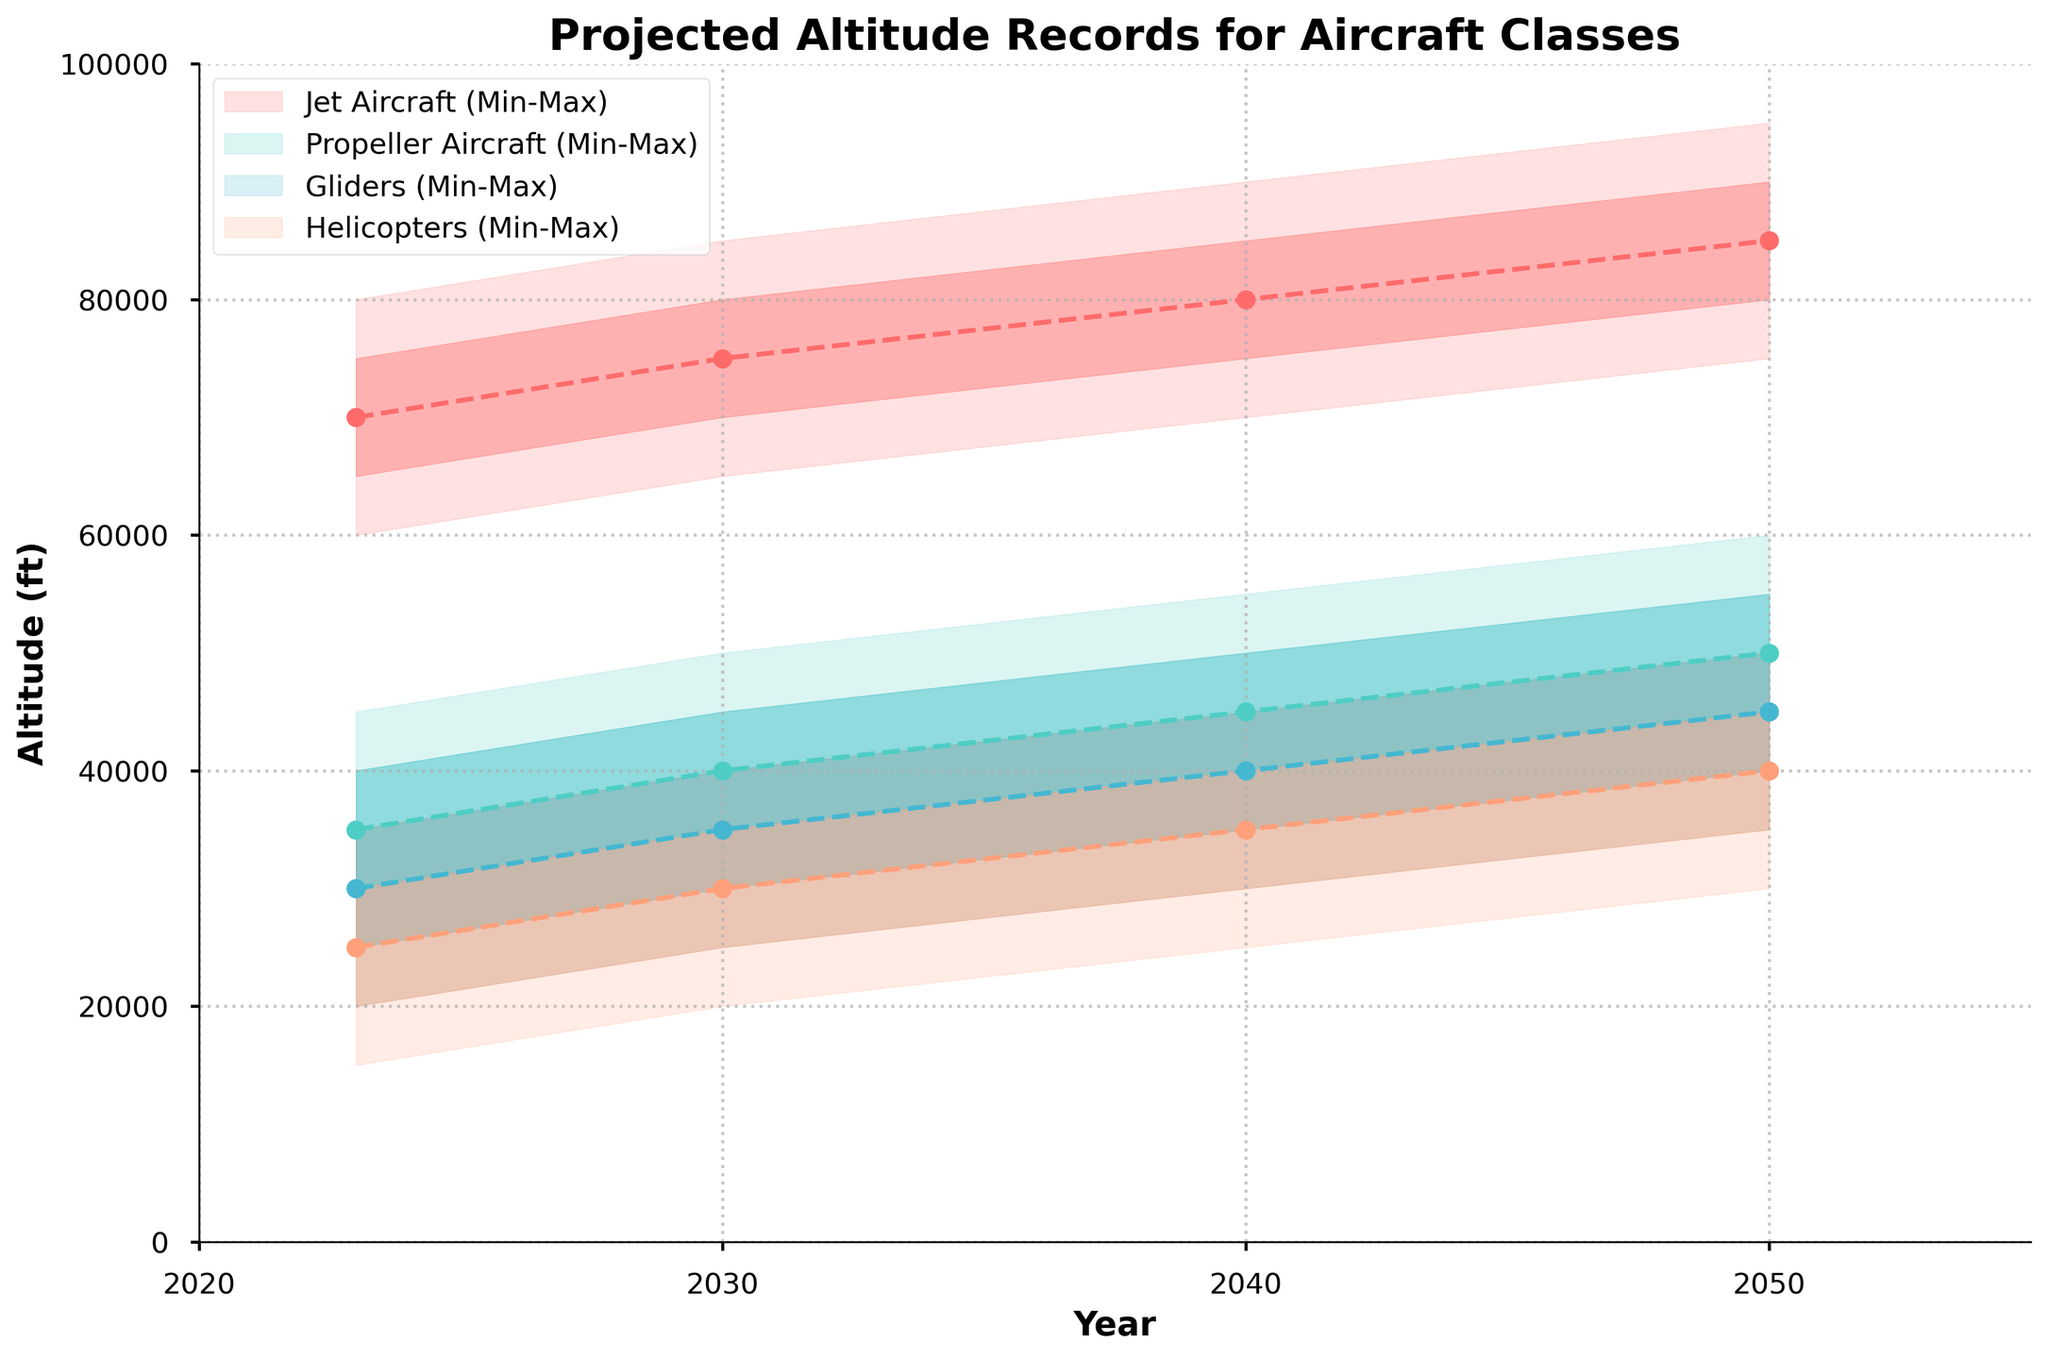What is the title of the figure? The title of the figure is located at the top and provides the main description of the information displayed.
Answer: Projected Altitude Records for Aircraft Classes In which year is the median altitude for helicopters projected to be 35,000 feet? To find this, look at the year corresponding to a median altitude of 35,000 feet in the helicopters section of the chart.
Answer: 2040 What is the upper quartile altitude for jet aircraft in 2023? Look at the 2023 section for jet aircraft and find the upper quartile value, which is the second highest value represented by the shaded area.
Answer: 75,000 feet In 2050, how does the maximum altitude for propeller aircraft compare to that of gliders? Compare the maximum altitude values for both propeller aircraft and gliders in the year 2050.
Answer: The maximum altitude for propeller aircraft (60,000 feet) is higher than that of gliders (55,000 feet) How has the median altitude for gliders changed from 2023 to 2050? Identify the median altitude for gliders in 2023 and 2050 and calculate the difference.
Answer: It increased by 15,000 feet (from 30,000 to 45,000 feet) What is the projected altitude range for helicopters in 2030? The range is determined by the minimum and maximum values for helicopters in 2030.
Answer: 20,000 - 40,000 feet Between which years do jet aircraft show the most significant increase in median altitude? To determine this, compare the median altitude values for jet aircraft across all years and find the period with the largest increase.
Answer: Between 2023 and 2030 In 2040, which aircraft class has the smallest interquartile range? The interquartile range is the difference between the upper and lower quartile values. Calculate this for each aircraft class in 2040.
Answer: Gliders (10,000 feet) By how much is the maximum altitude for propeller aircraft expected to increase from 2023 to 2030? Find the maximum altitude for propeller aircraft in 2023 and 2030 and calculate the difference.
Answer: 5,000 feet 